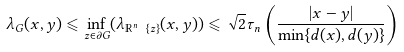<formula> <loc_0><loc_0><loc_500><loc_500>\lambda _ { G } ( x , y ) \leqslant \inf _ { z \in \partial G } ( \lambda _ { \mathbb { R } ^ { n } \ \{ z \} } ( x , y ) ) \leqslant \sqrt { 2 } \tau _ { n } \left ( \frac { | x - y | } { \min \{ d ( x ) , d ( y ) \} } \right )</formula> 